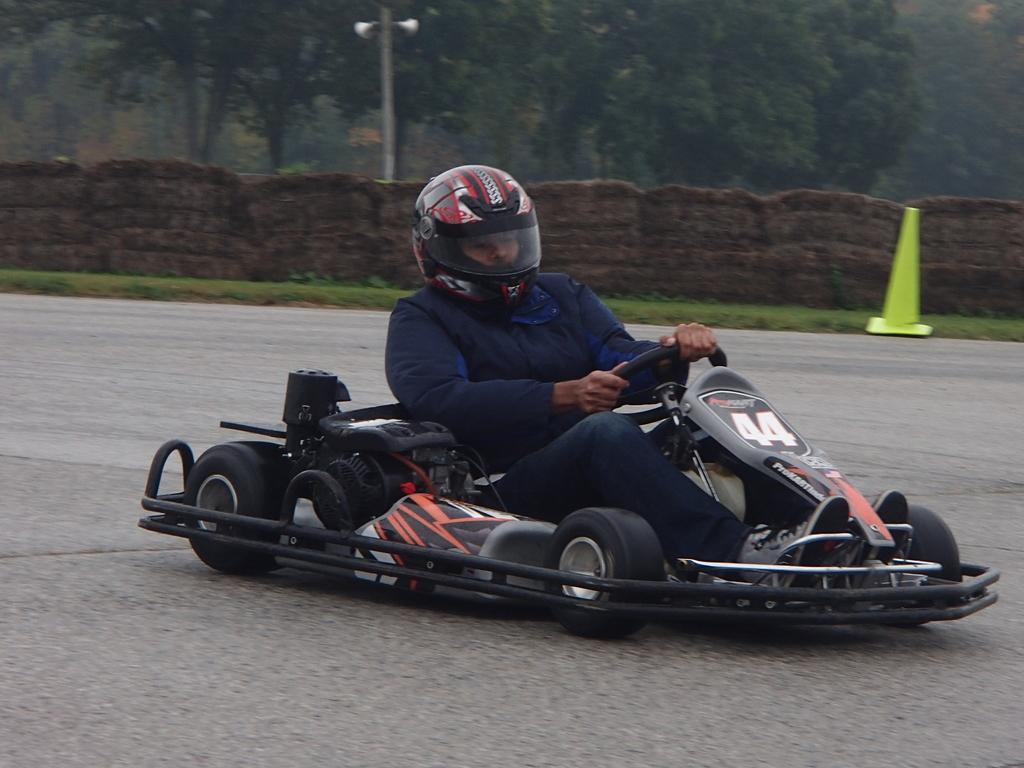Please provide a concise description of this image. In this image, we can see a person wearing a helmet and driving a vehicle. There is a wall in the middle of the image. There is a pole and trees at the top of the image. There is a divider cone on the right side of the image. 